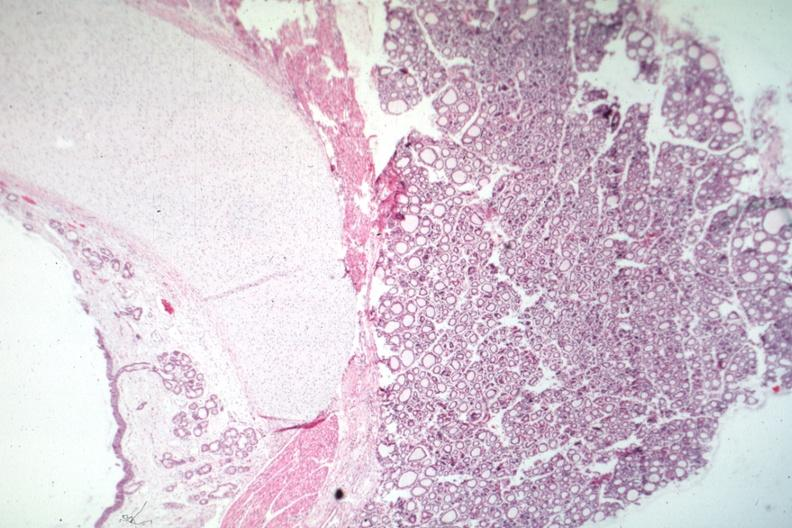s thyroid present?
Answer the question using a single word or phrase. Yes 